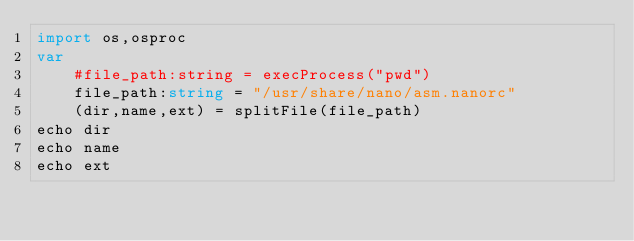<code> <loc_0><loc_0><loc_500><loc_500><_Nim_>import os,osproc
var
    #file_path:string = execProcess("pwd")
    file_path:string = "/usr/share/nano/asm.nanorc"
    (dir,name,ext) = splitFile(file_path)
echo dir
echo name
echo ext
</code> 